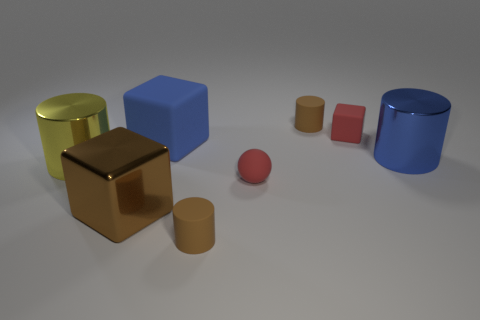Subtract all gray blocks. How many brown cylinders are left? 2 Subtract all blue cylinders. How many cylinders are left? 3 Subtract all large blue cylinders. How many cylinders are left? 3 Subtract 2 cylinders. How many cylinders are left? 2 Subtract all red cylinders. Subtract all gray balls. How many cylinders are left? 4 Add 1 red matte blocks. How many objects exist? 9 Subtract all cubes. How many objects are left? 5 Subtract 0 purple spheres. How many objects are left? 8 Subtract all tiny gray shiny blocks. Subtract all small red matte cubes. How many objects are left? 7 Add 3 small matte things. How many small matte things are left? 7 